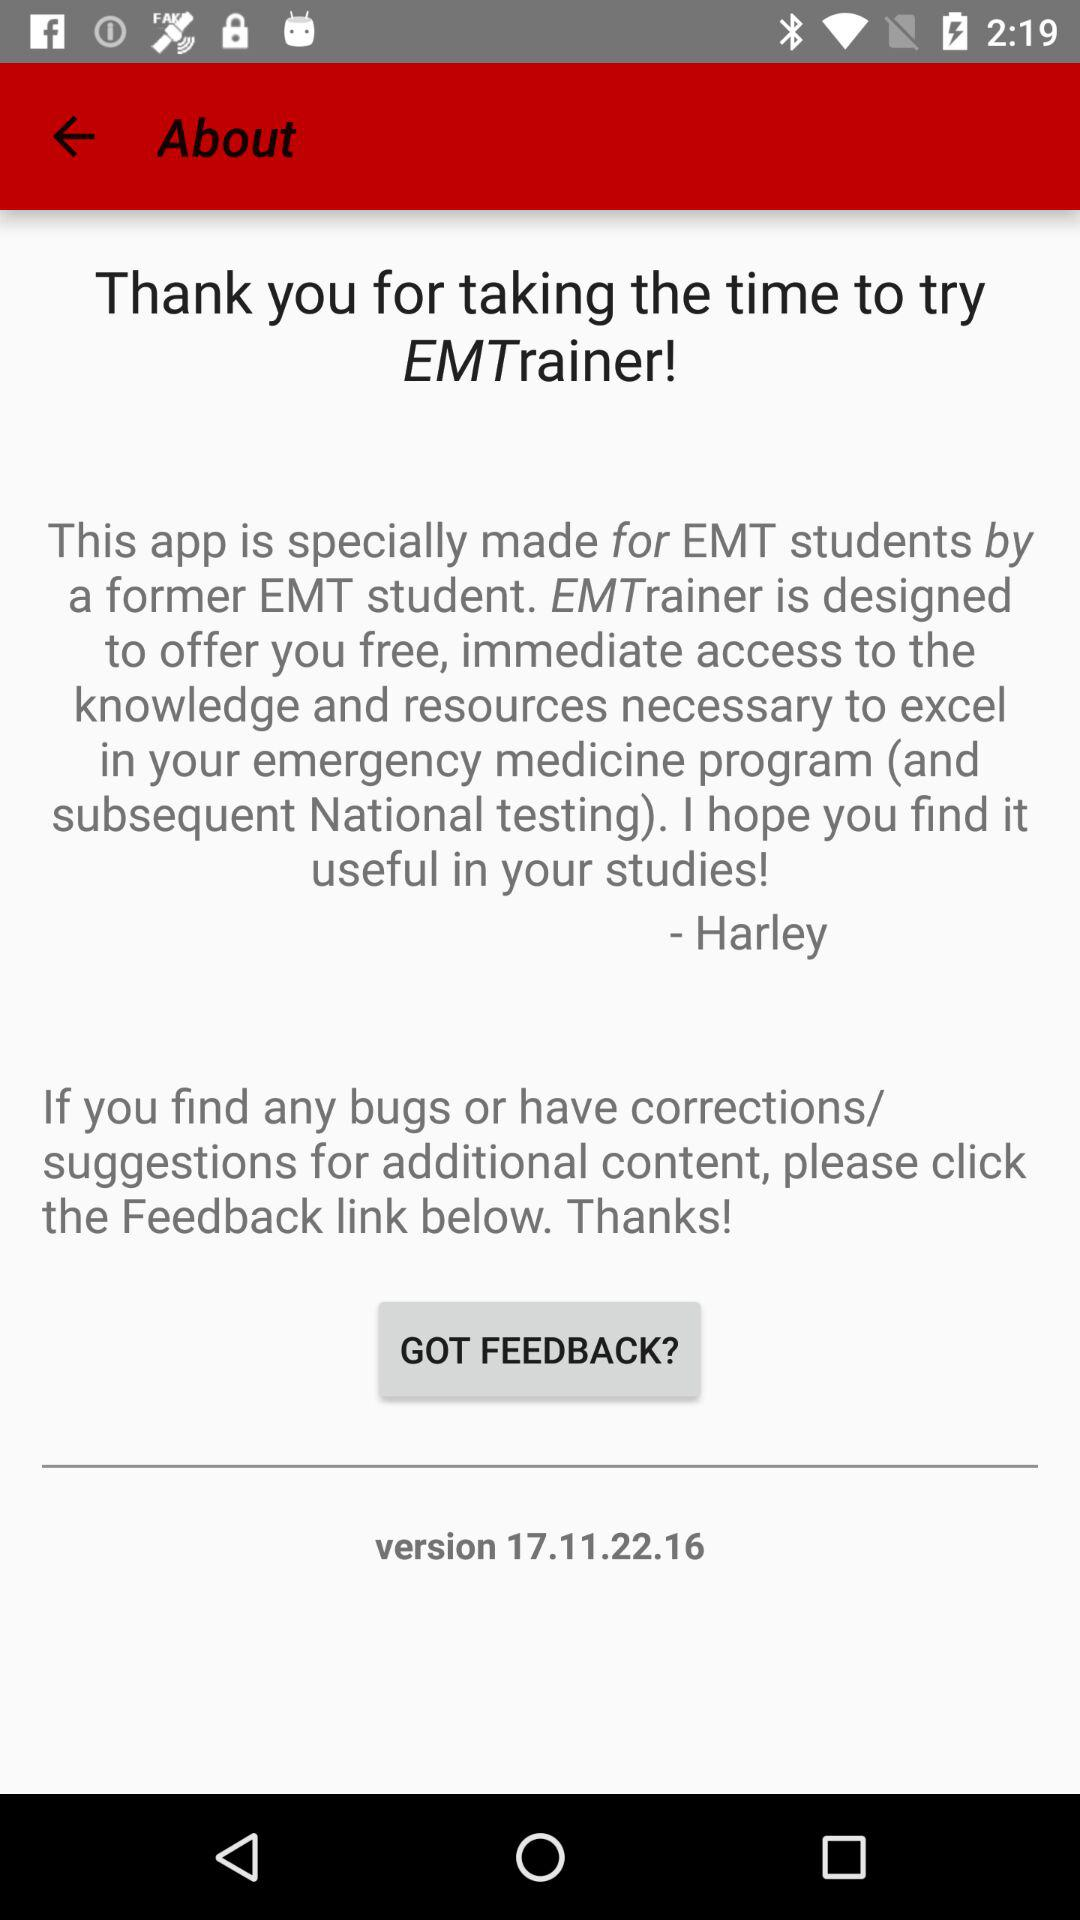What version of the application is being used? The used version of the application is 17.11.22.16. 